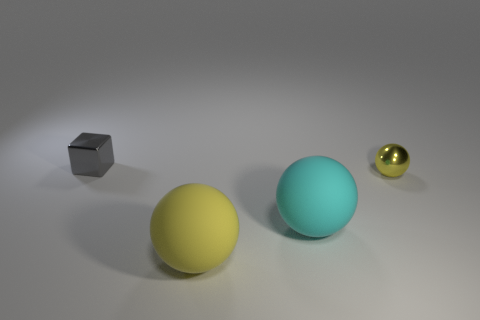Subtract all yellow matte spheres. How many spheres are left? 2 Subtract all yellow spheres. How many spheres are left? 1 Subtract 3 balls. How many balls are left? 0 Add 4 red matte cylinders. How many objects exist? 8 Subtract all red cylinders. How many red blocks are left? 0 Add 3 matte things. How many matte things are left? 5 Add 2 cyan spheres. How many cyan spheres exist? 3 Subtract 0 gray balls. How many objects are left? 4 Subtract all cubes. How many objects are left? 3 Subtract all gray spheres. Subtract all yellow blocks. How many spheres are left? 3 